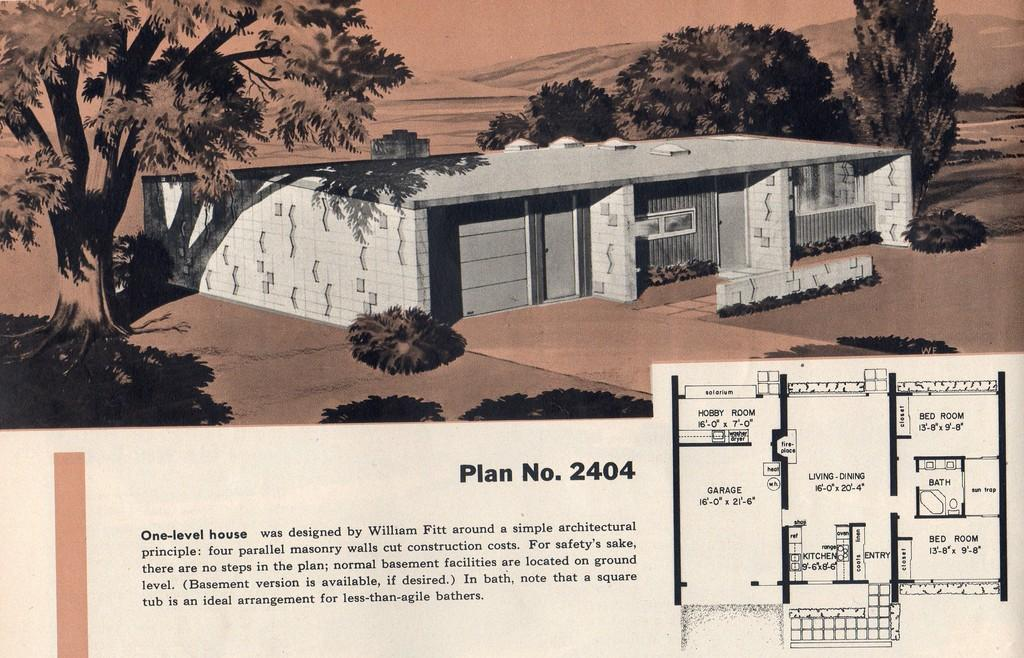What is the main structure visible in the image? There is a building in the image. What is unique about the building? Trees are present on the building. What else can be seen in the image besides the building? There is text and a plan beside the text in the image. Can you see the man walking on the moon in the image? There is no man walking on the moon in the image; it only features a building with trees, text, and a plan. 